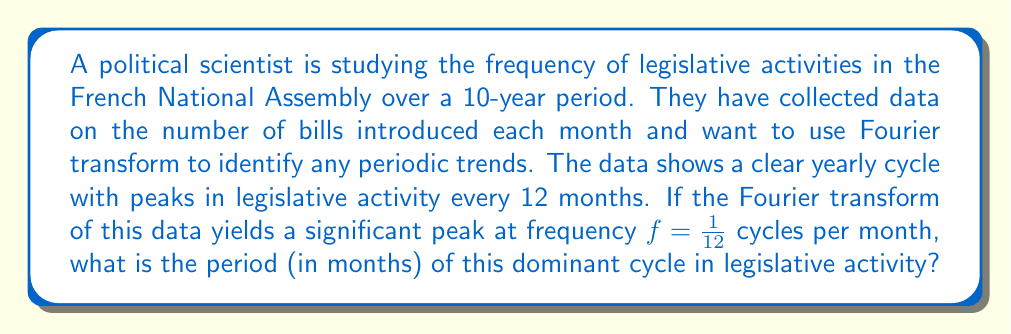What is the answer to this math problem? To solve this problem, we need to understand the relationship between frequency and period in Fourier analysis:

1) In Fourier analysis, frequency ($f$) and period ($T$) are inversely related:

   $$T = \frac{1}{f}$$

2) We are given that the Fourier transform shows a significant peak at frequency:

   $$f = \frac{1}{12} \text{ cycles per month}$$

3) To find the period, we simply need to take the reciprocal of this frequency:

   $$T = \frac{1}{f} = \frac{1}{\frac{1}{12}} = 12 \text{ months}$$

4) This result aligns with the observation in the question that there are peaks in legislative activity every 12 months, corresponding to a yearly cycle.

In the context of French politics, this yearly cycle could be related to the legislative session calendar, budget cycles, or other annual patterns in parliamentary activity. The Fourier transform has helped to quantify and confirm this periodic trend in the data.
Answer: The period of the dominant cycle in legislative activity is 12 months. 